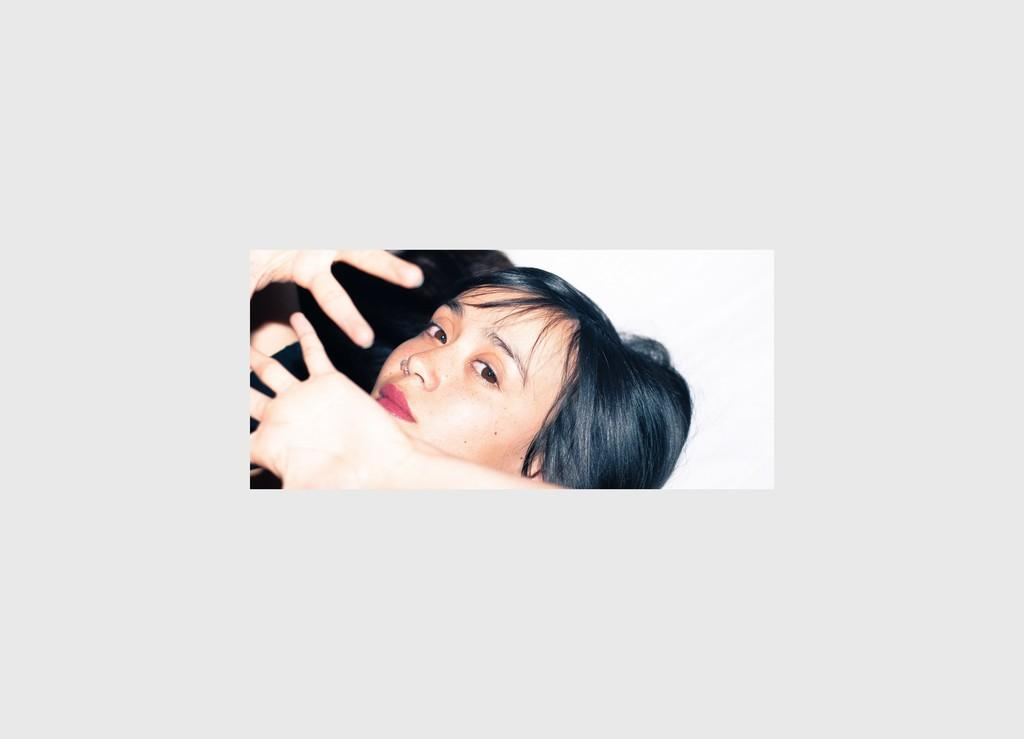Who is the main subject in the image? There is a woman in the image. What is the woman doing in the image? The woman has her head placed on a white surface. Are there any other people or objects in the image? There are hands placed below the woman's face. How many pigs can be seen in the image? There are no pigs present in the image. What type of rat is interacting with the woman in the image? There is no rat present in the image. 